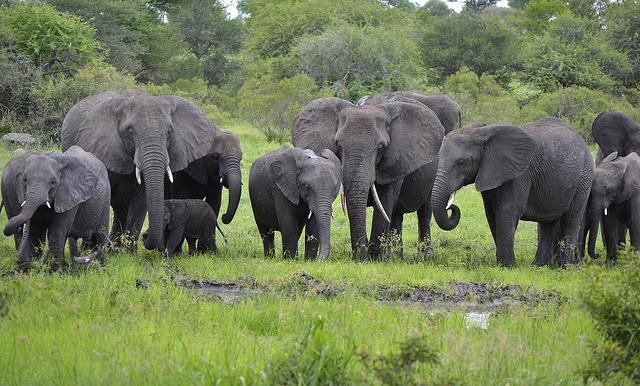How many elephants are in the picture?
Give a very brief answer. 8. 